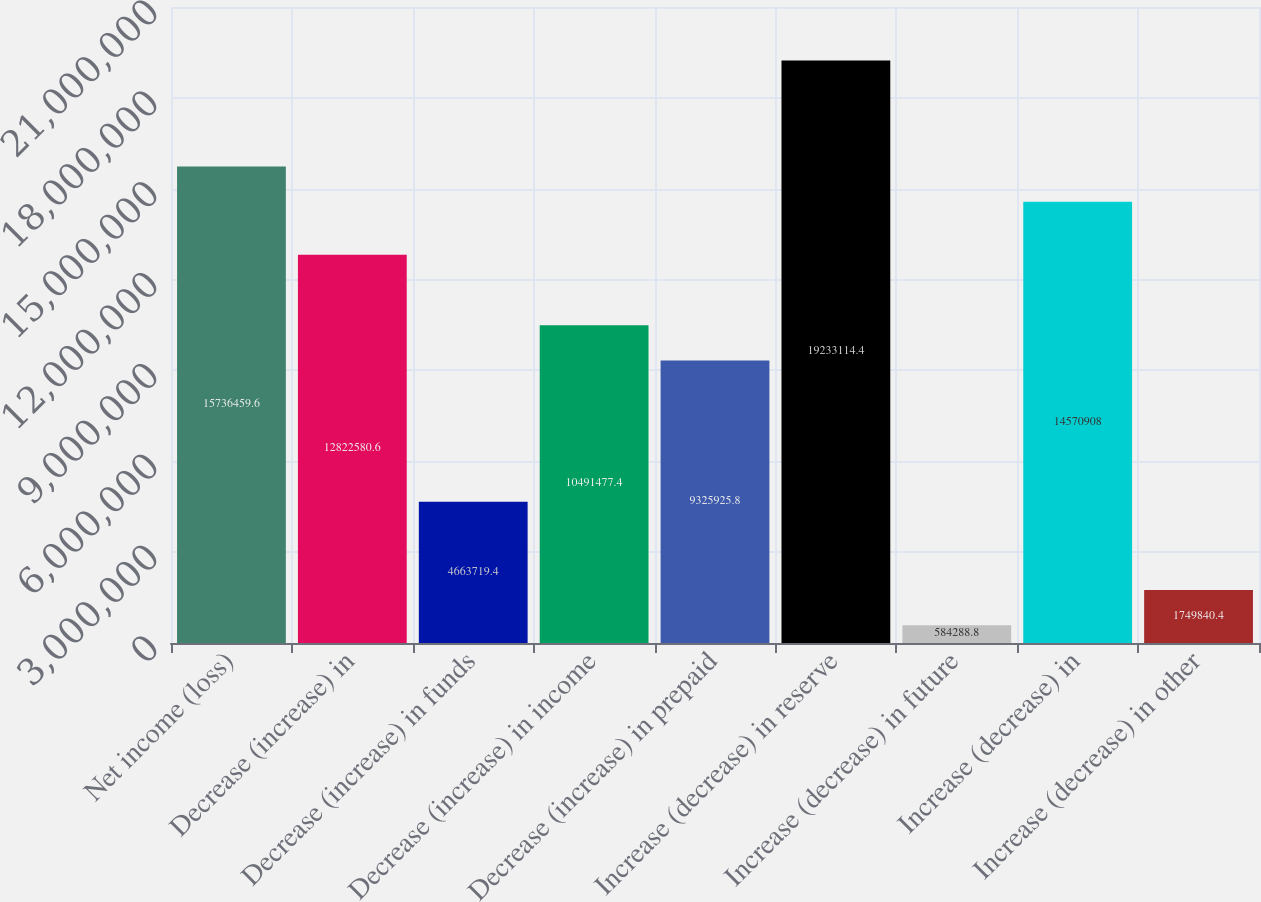Convert chart to OTSL. <chart><loc_0><loc_0><loc_500><loc_500><bar_chart><fcel>Net income (loss)<fcel>Decrease (increase) in<fcel>Decrease (increase) in funds<fcel>Decrease (increase) in income<fcel>Decrease (increase) in prepaid<fcel>Increase (decrease) in reserve<fcel>Increase (decrease) in future<fcel>Increase (decrease) in<fcel>Increase (decrease) in other<nl><fcel>1.57365e+07<fcel>1.28226e+07<fcel>4.66372e+06<fcel>1.04915e+07<fcel>9.32593e+06<fcel>1.92331e+07<fcel>584289<fcel>1.45709e+07<fcel>1.74984e+06<nl></chart> 